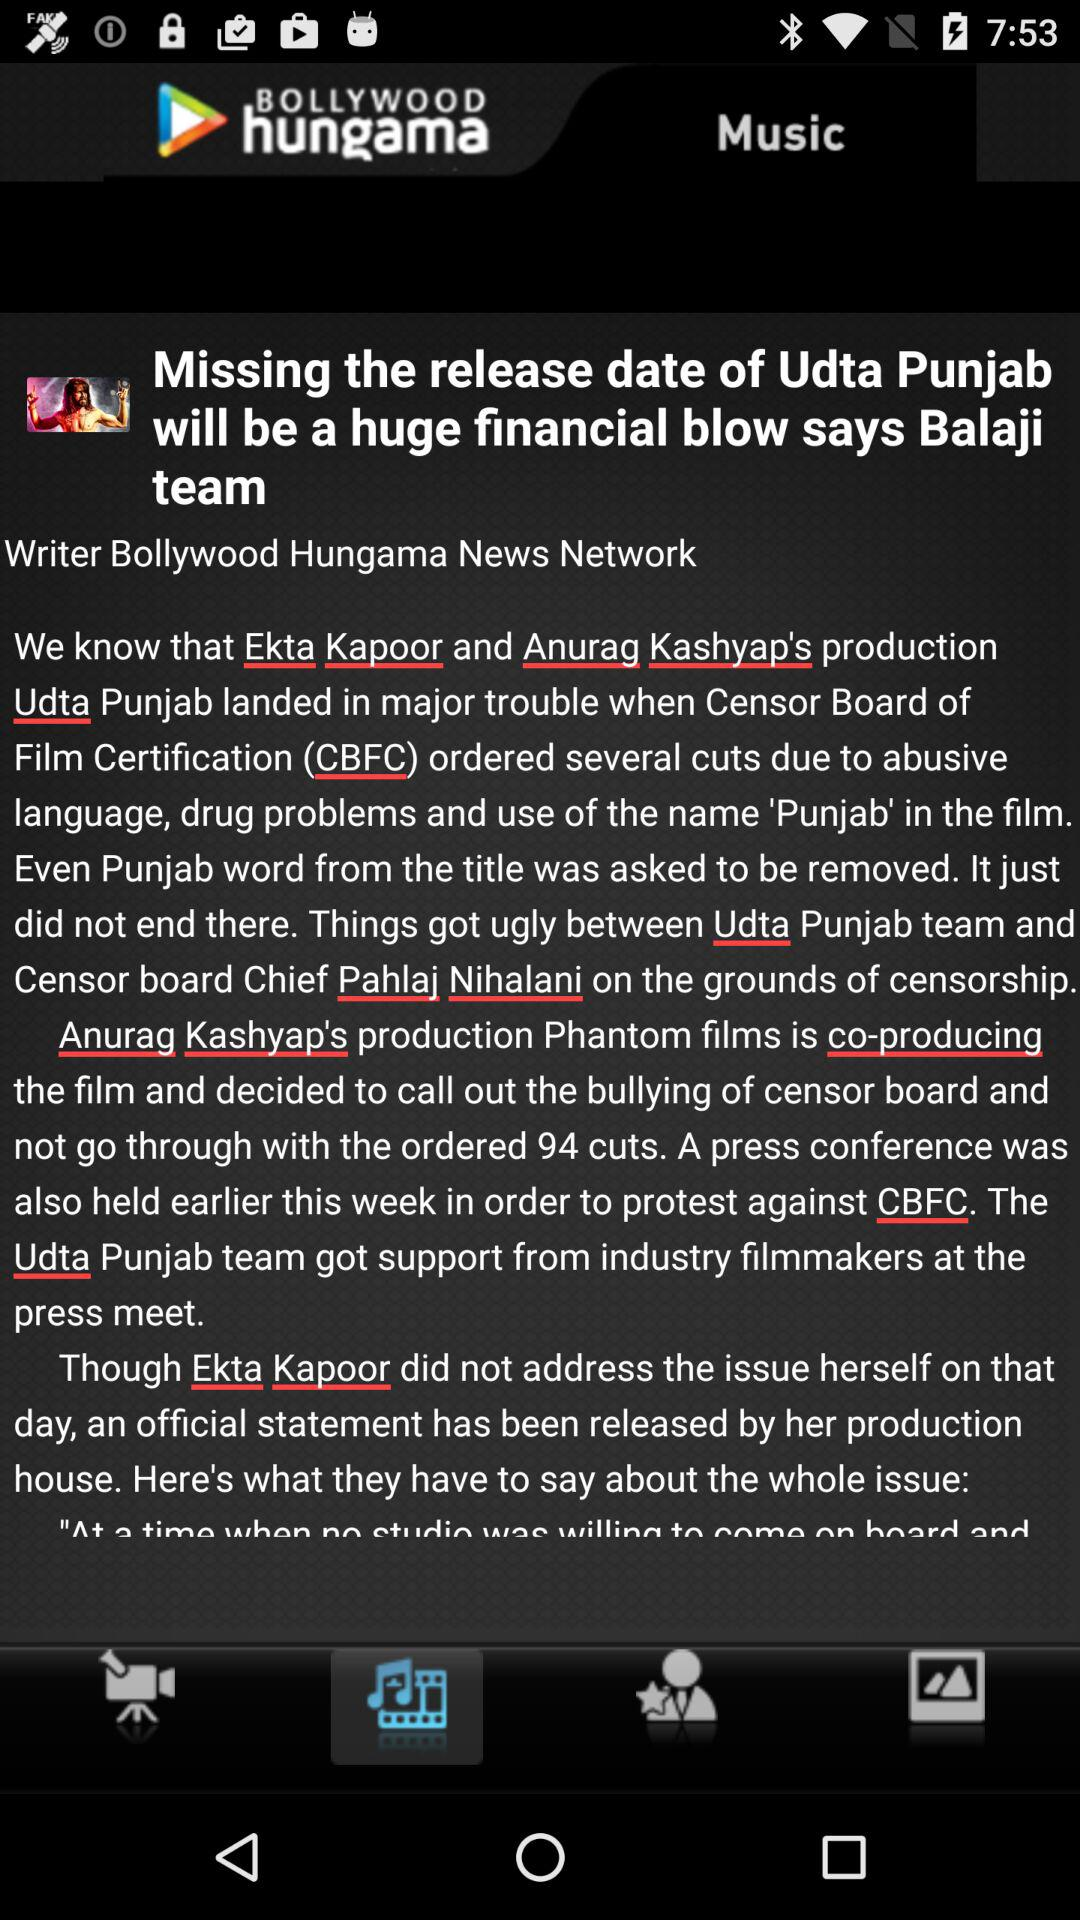Who is the writer of the article? The writer of the article is Bollywood Hungama News Network. 